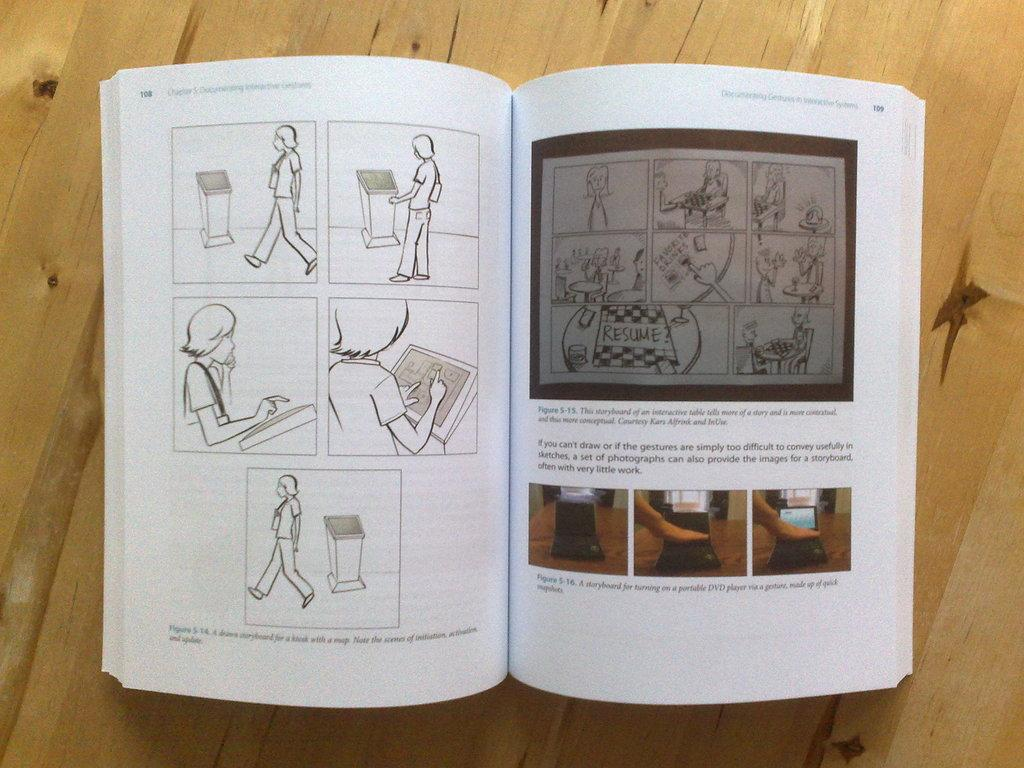<image>
Provide a brief description of the given image. the page of a book that is 109 